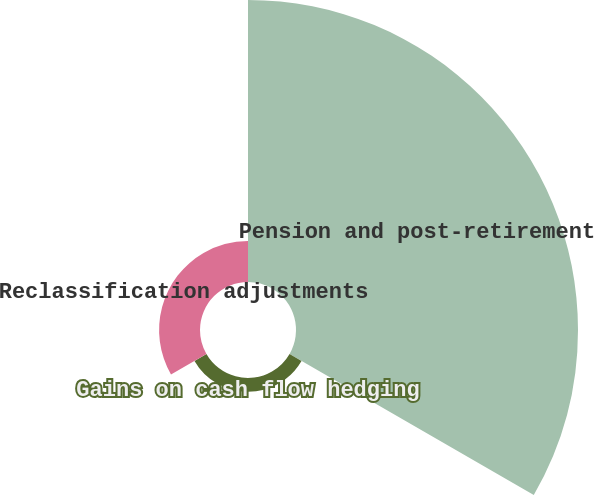<chart> <loc_0><loc_0><loc_500><loc_500><pie_chart><fcel>Pension and post-retirement<fcel>Gains on cash flow hedging<fcel>Reclassification adjustments<nl><fcel>83.75%<fcel>4.1%<fcel>12.15%<nl></chart> 